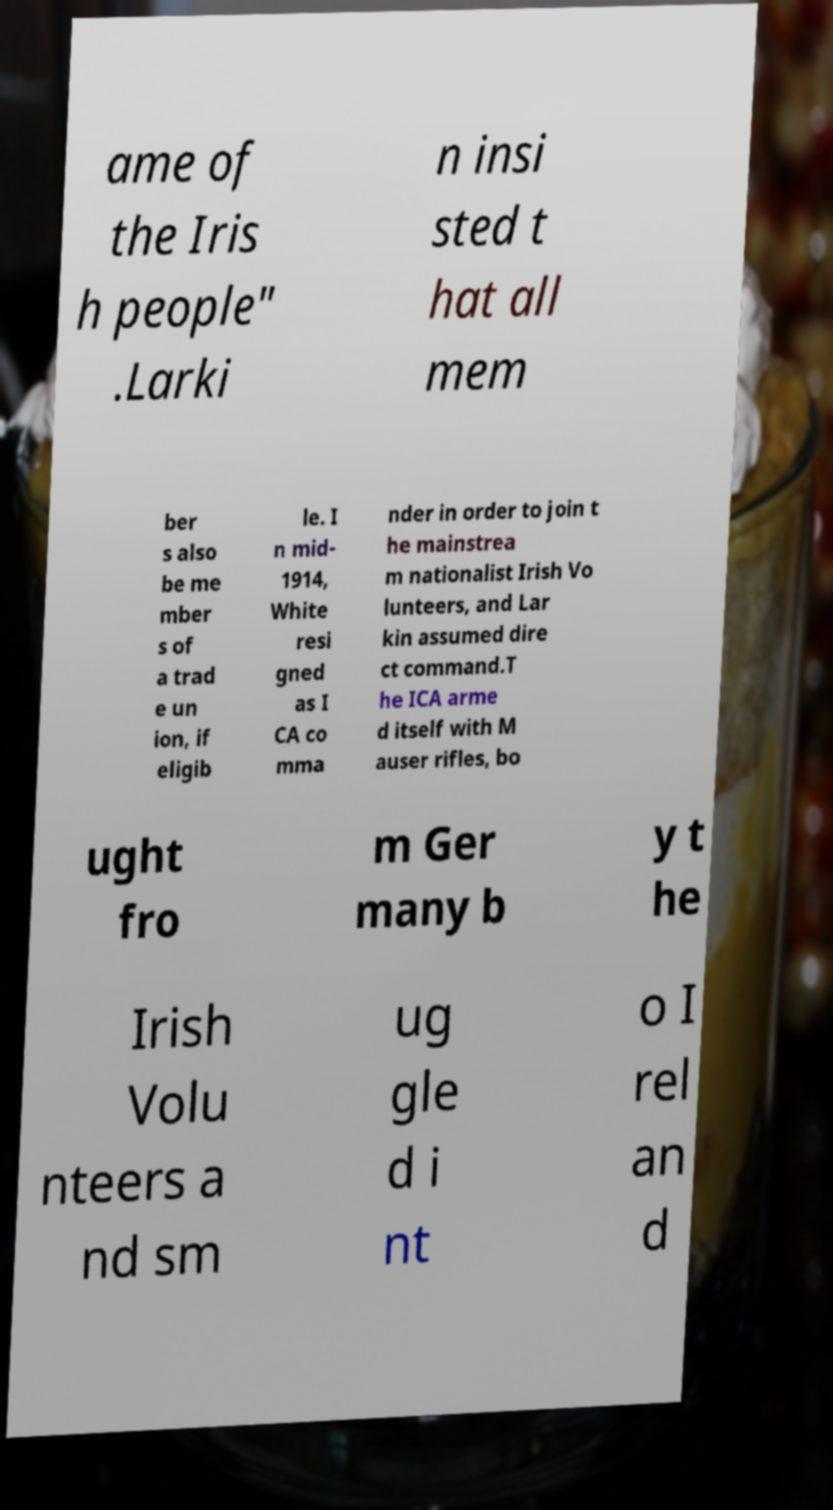Can you read and provide the text displayed in the image?This photo seems to have some interesting text. Can you extract and type it out for me? ame of the Iris h people" .Larki n insi sted t hat all mem ber s also be me mber s of a trad e un ion, if eligib le. I n mid- 1914, White resi gned as I CA co mma nder in order to join t he mainstrea m nationalist Irish Vo lunteers, and Lar kin assumed dire ct command.T he ICA arme d itself with M auser rifles, bo ught fro m Ger many b y t he Irish Volu nteers a nd sm ug gle d i nt o I rel an d 